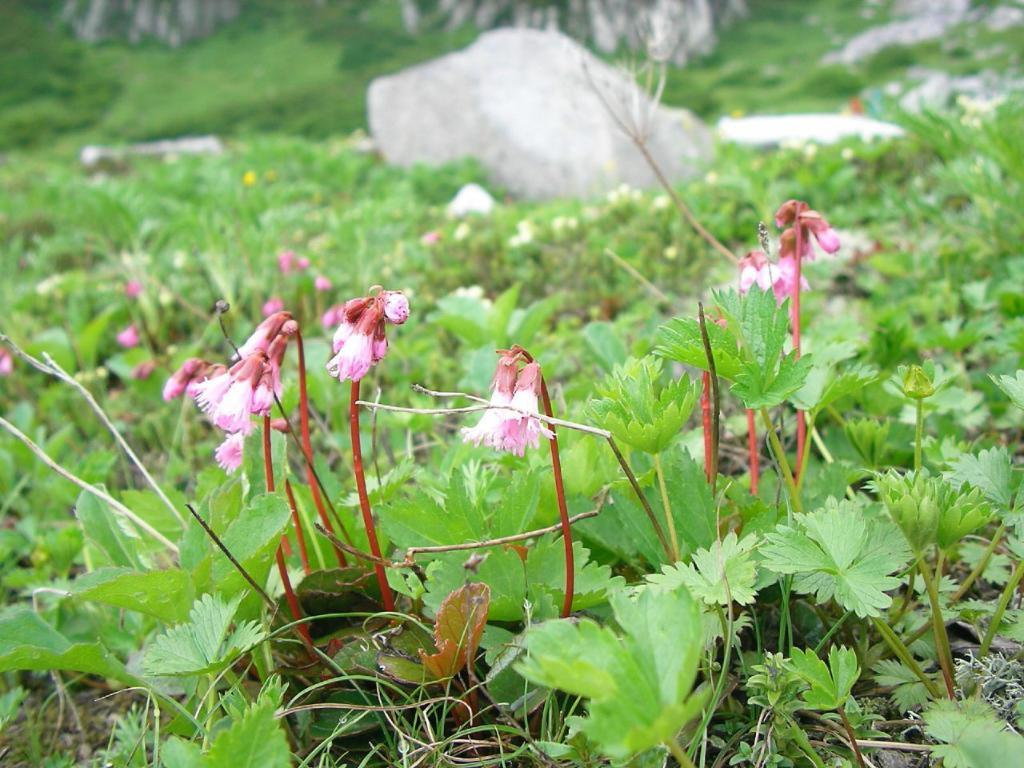What type of living organisms can be seen in the image? There are flowers in the image, which belong to a plant. How is the background of the image depicted? The background of the image is blurred. What other types of plants can be seen in the background? There are additional plants visible in the background. What natural elements are present in the background? Rocks and trees are visible in the background. How many children are playing with the jeans in the image? There are no children or jeans present in the image; it features flowers, plants, and natural elements in the background. 